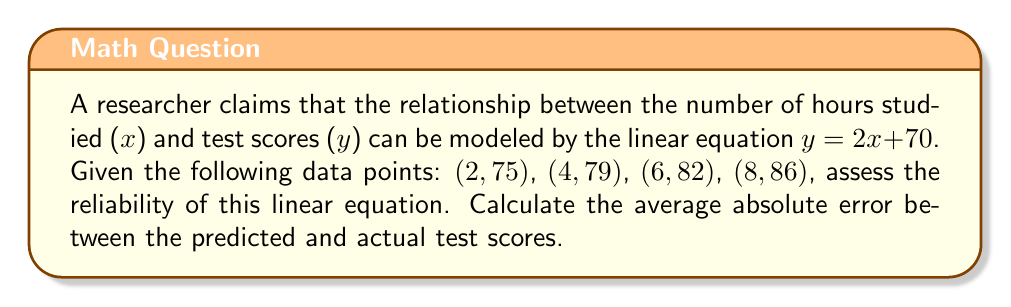Show me your answer to this math problem. To assess the reliability of the linear equation, we'll follow these steps:

1) Calculate the predicted y-values using the given equation $y = 2x + 70$ for each x-value.
2) Compare the predicted y-values with the actual y-values.
3) Calculate the absolute error for each data point.
4) Find the average of these absolute errors.

Step 1: Predicted y-values
For x = 2: $y = 2(2) + 70 = 74$
For x = 4: $y = 2(4) + 70 = 78$
For x = 6: $y = 2(6) + 70 = 82$
For x = 8: $y = 2(8) + 70 = 86$

Step 2 & 3: Compare and calculate absolute errors
For (2, 75): |74 - 75| = 1
For (4, 79): |78 - 79| = 1
For (6, 82): |82 - 82| = 0
For (8, 86): |86 - 86| = 0

Step 4: Calculate the average absolute error
Average absolute error = $(1 + 1 + 0 + 0) \div 4 = 0.5$

The average absolute error of 0.5 points indicates that, on average, the predicted scores deviate from the actual scores by 0.5 points. This suggests that the linear equation is relatively reliable for modeling the relationship between study hours and test scores.
Answer: 0.5 